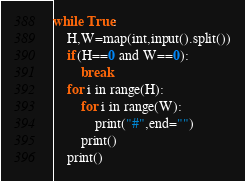<code> <loc_0><loc_0><loc_500><loc_500><_Python_>while True:
    H,W=map(int,input().split())
    if(H==0 and W==0):
        break
    for i in range(H):
        for i in range(W):
            print("#",end="")
        print()
    print()
</code> 